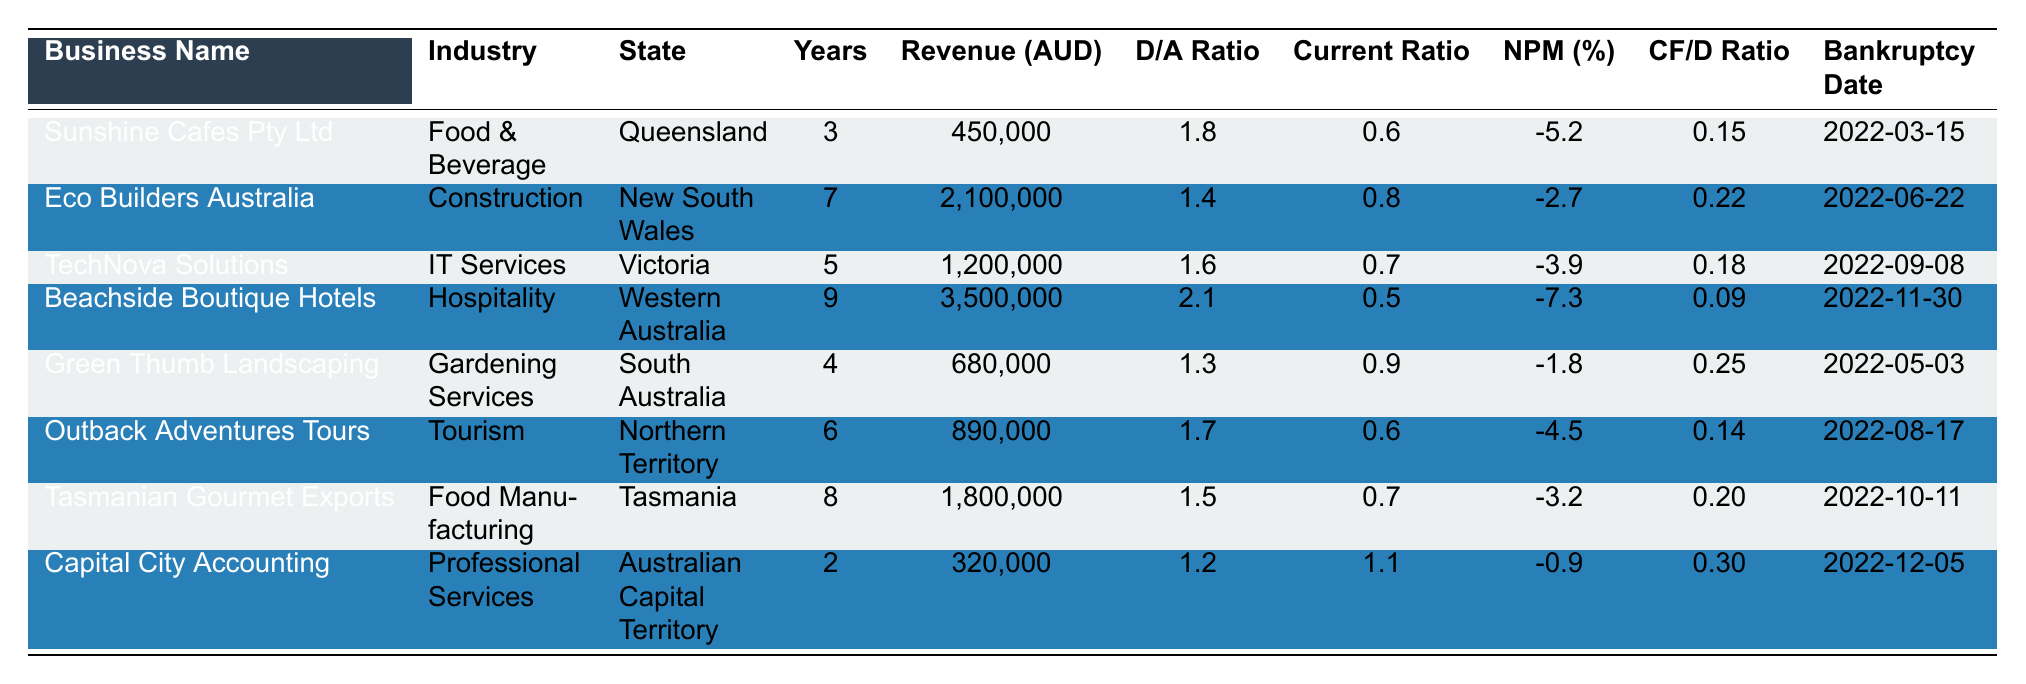What is the total annual revenue of all businesses listed in the table? To obtain the total annual revenue, we add the annual revenues of each business: 450,000 + 2,100,000 + 1,200,000 + 3,500,000 + 680,000 + 890,000 + 1,800,000 + 320,000 = 10,130,000.
Answer: 10,130,000 AUD Which business has the highest debt-to-asset ratio? By examining the debt-to-asset ratios, we see Sunshine Cafes Pty Ltd has 1.8, Eco Builders Australia has 1.4, TechNova Solutions has 1.6, and so forth. Beachside Boutique Hotels has the highest ratio at 2.1.
Answer: Beachside Boutique Hotels What is the current ratio for Capital City Accounting? The current ratio for Capital City Accounting is directly listed in the table as 1.1.
Answer: 1.1 How many businesses had a net profit margin of less than -5%? We check the net profit margins of each business. Sunshine Cafes Pty Ltd at -5.2%, Beachside Boutique Hotels at -7.3%, and Outback Adventures Tours at -4.5%. Two businesses have a net profit margin below -5%.
Answer: 2 What is the common characteristic of businesses that filed for bankruptcy in the food industry? Looking at the food industry businesses in the table, Sunshine Cafes Pty Ltd has a net profit margin of -5.2% and Tasmanian Gourmet Exports has -3.2%, indicating both have negative margins, which may suggest financial struggles leading to bankruptcy.
Answer: Both have negative net profit margins Calculate the average years in operation for all businesses listed. To find the average years, sum the years in operation: 3 + 7 + 5 + 9 + 4 + 6 + 8 + 2 = 44. Then divide by the number of businesses (8): 44 / 8 = 5.5.
Answer: 5.5 years What percentage of the businesses had a debt-to-asset ratio greater than 1.5? Out of 8 businesses, Beachside Boutique Hotels has 2.1, TechNova Solutions has 1.6, and Sunshine Cafes Pty Ltd has 1.8, making it 3 businesses with ratios greater than 1.5. Hence, the percentage is (3 / 8) * 100 = 37.5%.
Answer: 37.5% Which state has the business with the maximum annual revenue? Beachside Boutique Hotels has the maximum annual revenue of 3,500,000 AUD and is located in Western Australia.
Answer: Western Australia Is there any business with a current ratio below 0.6? By checking the current ratios, Sunshine Cafes Pty Ltd has a ratio of 0.6, Beachside Boutique Hotels has 0.5, confirming that it is the only business with a ratio below 0.6.
Answer: Yes What is the trend of net profit margins for businesses with more than 5 years of operation? The businesses with more than 5 years of operation are Eco Builders Australia, TechNova Solutions, Beachside Boutique Hotels, and Tasmanian Gourmet Exports. Their net profit margins are -2.7%, -3.9%, -7.3%, and -3.2%, indicating that all these businesses have negative margins, suggesting financial difficulties as they accrued more operational experience.
Answer: All have negative net profit margins 